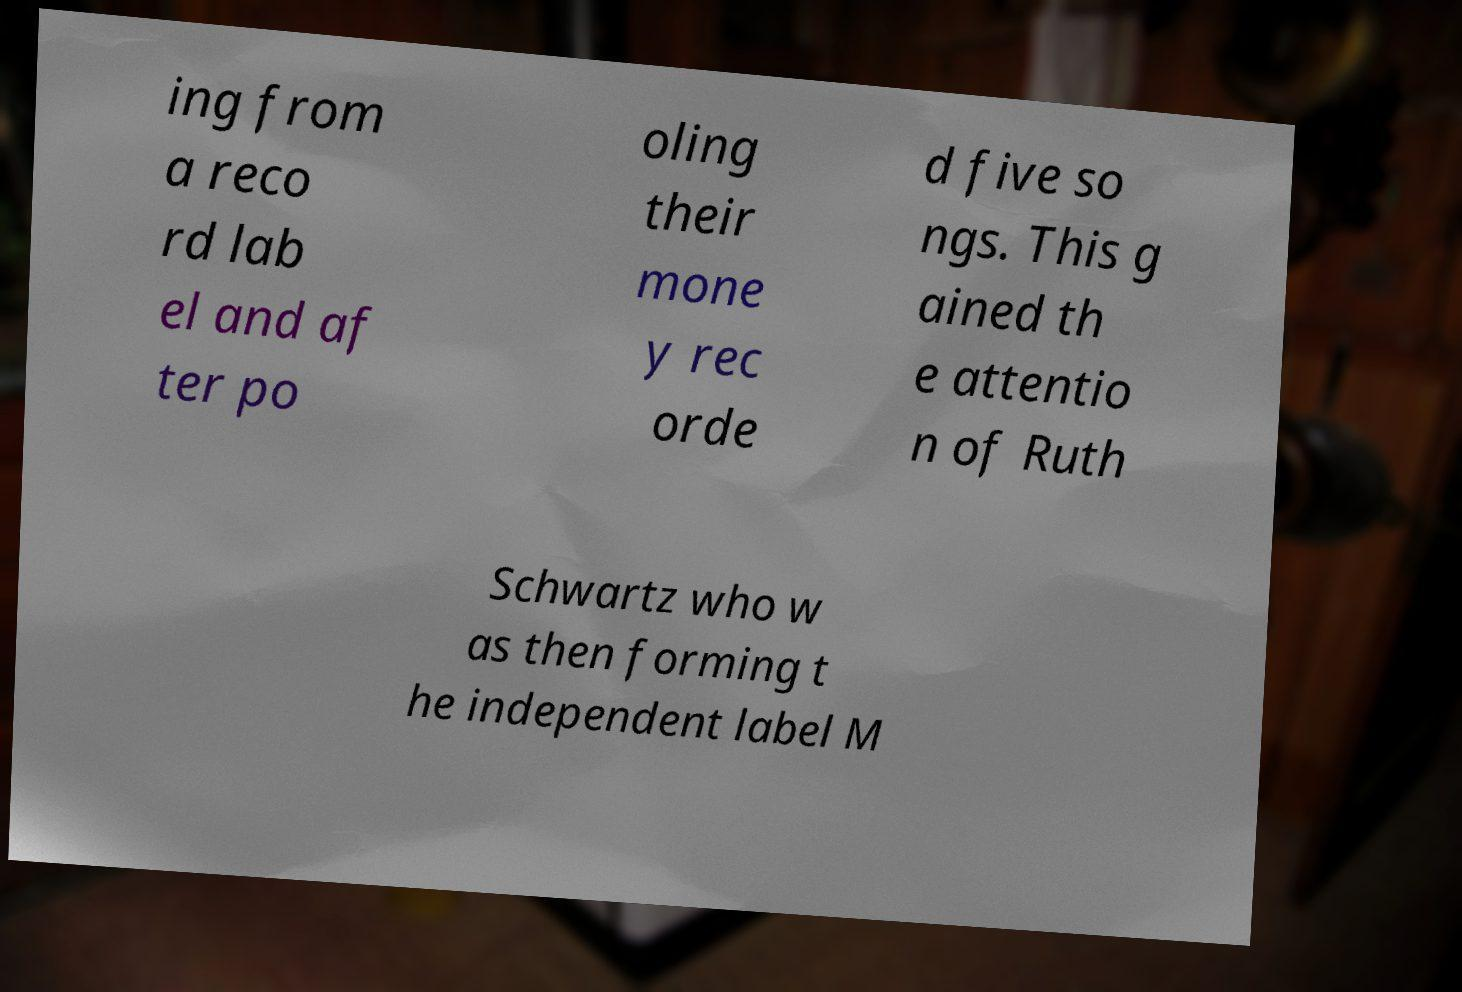Could you assist in decoding the text presented in this image and type it out clearly? ing from a reco rd lab el and af ter po oling their mone y rec orde d five so ngs. This g ained th e attentio n of Ruth Schwartz who w as then forming t he independent label M 